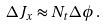<formula> <loc_0><loc_0><loc_500><loc_500>\Delta J _ { x } \approx N _ { t } \Delta \phi \, .</formula> 